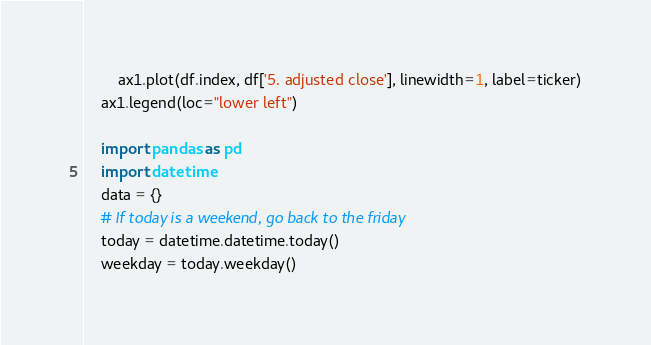<code> <loc_0><loc_0><loc_500><loc_500><_Python_>        ax1.plot(df.index, df['5. adjusted close'], linewidth=1, label=ticker)
    ax1.legend(loc="lower left")

    import pandas as pd
    import datetime
    data = {}
    # If today is a weekend, go back to the friday
    today = datetime.datetime.today()
    weekday = today.weekday()</code> 